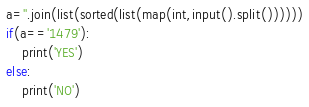<code> <loc_0><loc_0><loc_500><loc_500><_Python_>a=''.join(list(sorted(list(map(int,input().split())))))
if(a=='1479'):
	print('YES')
else:
	print('NO')


</code> 